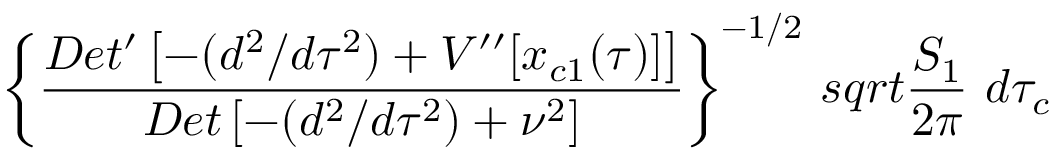<formula> <loc_0><loc_0><loc_500><loc_500>\left \{ { \frac { D e t ^ { \prime } \left [ - ( d ^ { 2 } / d \tau ^ { 2 } ) + V ^ { \prime \prime } [ x _ { c 1 } ( \tau ) ] \right ] } { D e t \left [ - ( d ^ { 2 } / d \tau ^ { 2 } ) + \nu ^ { 2 } \right ] } } \right \} ^ { - 1 / 2 } \, s q r t { { \frac { S _ { 1 } } { 2 \pi } } } \ d \tau _ { c }</formula> 